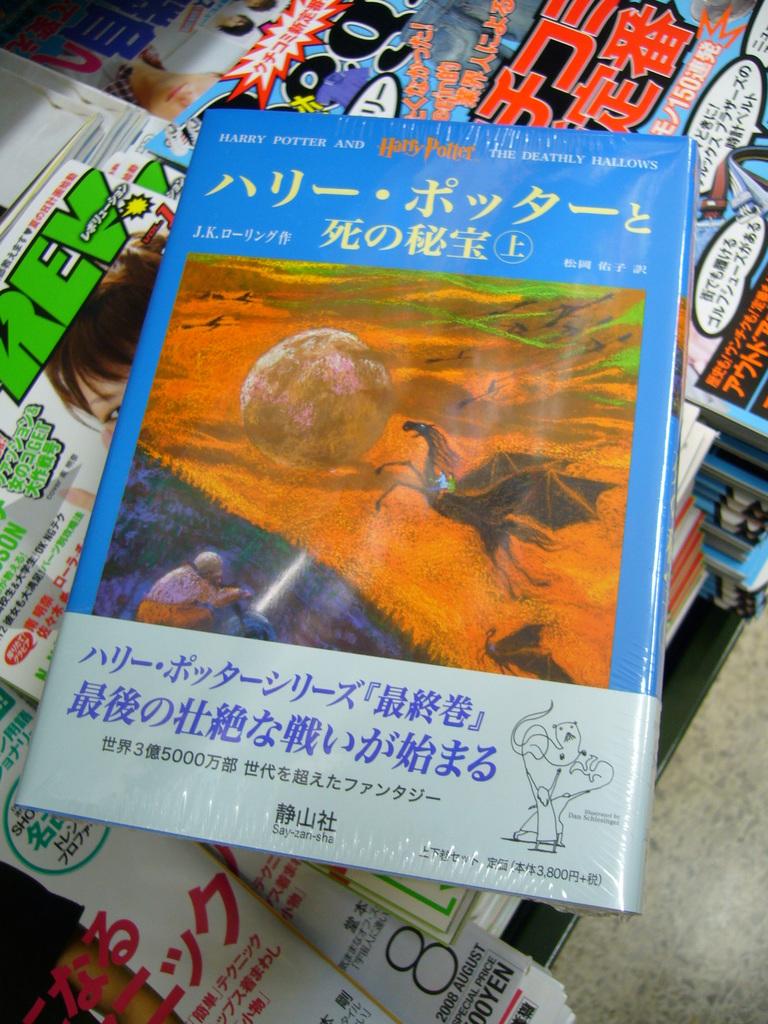What orange english words are at the top of the page?
Provide a short and direct response. Harry potter. 